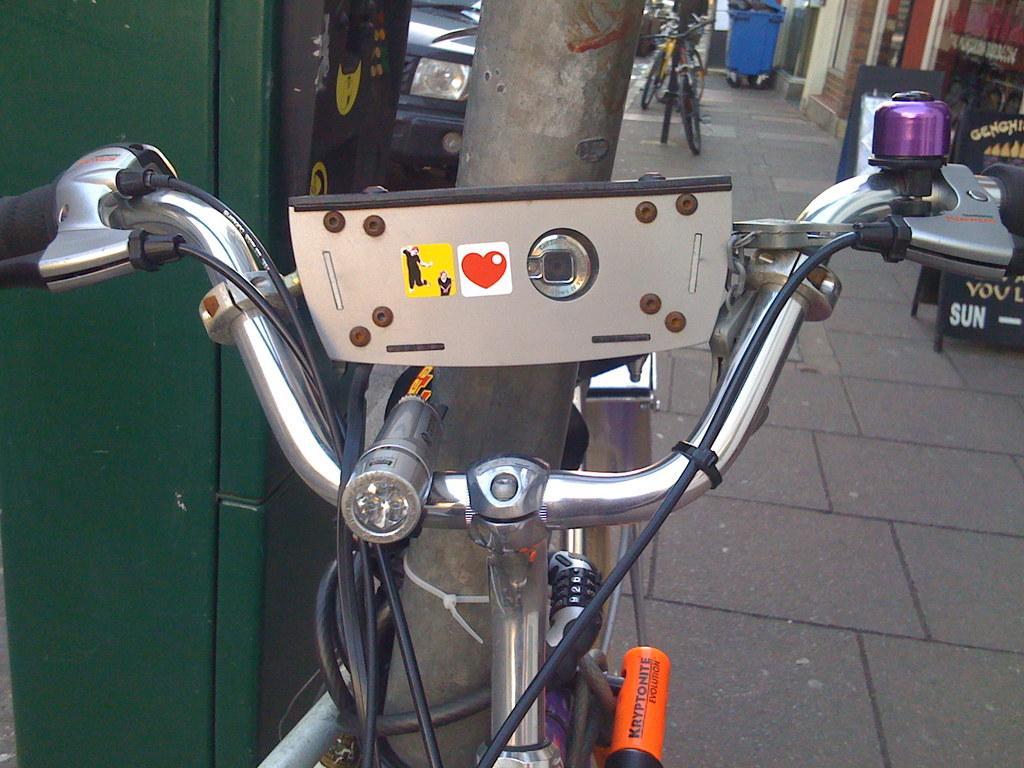Please provide a concise description of this image. In this picture we can see a bicycle and a pole in the front, on the left side there is a cabinet, we can see bicycles, a car and a dustbin in the background, on the right side there is a board. 